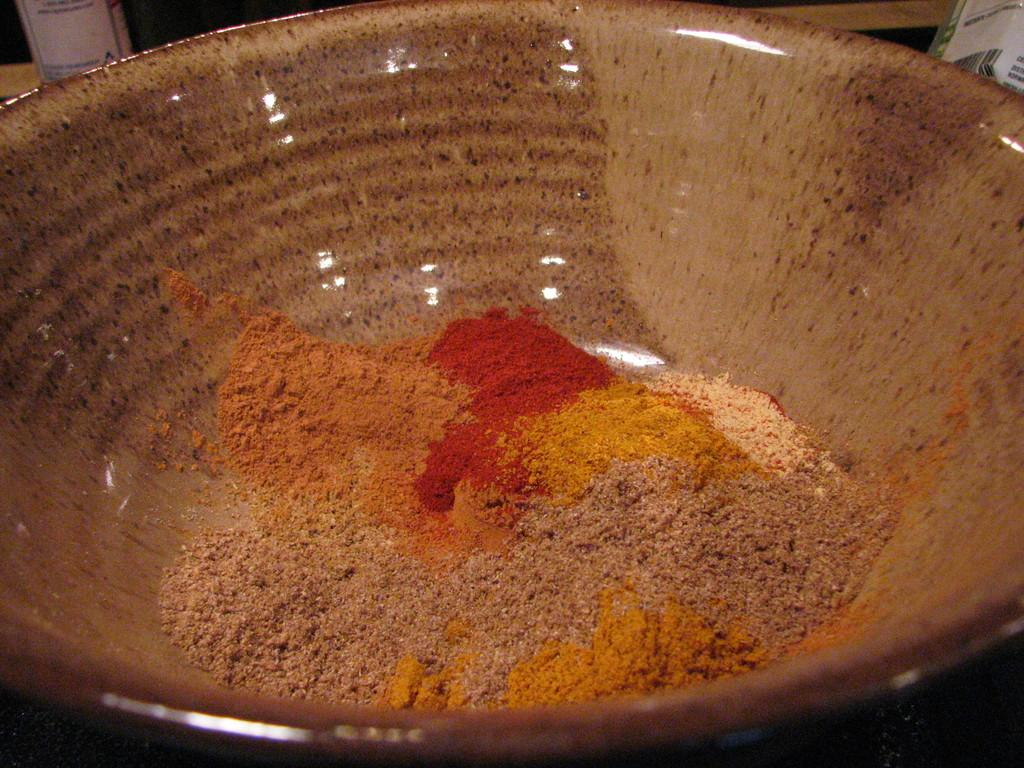What is located in the bowl in the image? There is something in a bowl in the image, but the specific contents are not mentioned. What type of silk is being used to create the van's interior in the image? There is no van or silk present in the image; it only mentions something in a bowl. 